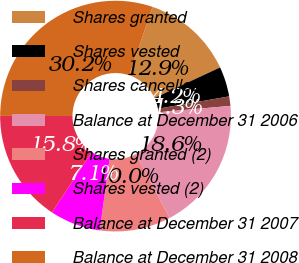Convert chart to OTSL. <chart><loc_0><loc_0><loc_500><loc_500><pie_chart><fcel>Shares granted<fcel>Shares vested<fcel>Shares cancelled<fcel>Balance at December 31 2006<fcel>Shares granted (2)<fcel>Shares vested (2)<fcel>Balance at December 31 2007<fcel>Balance at December 31 2008<nl><fcel>12.86%<fcel>4.2%<fcel>1.32%<fcel>18.63%<fcel>9.97%<fcel>7.09%<fcel>15.75%<fcel>30.18%<nl></chart> 